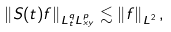Convert formula to latex. <formula><loc_0><loc_0><loc_500><loc_500>\left \| S ( t ) f \right \| _ { L ^ { q } _ { t } L ^ { p } _ { x y } } \lesssim \left \| f \right \| _ { L ^ { 2 } } ,</formula> 